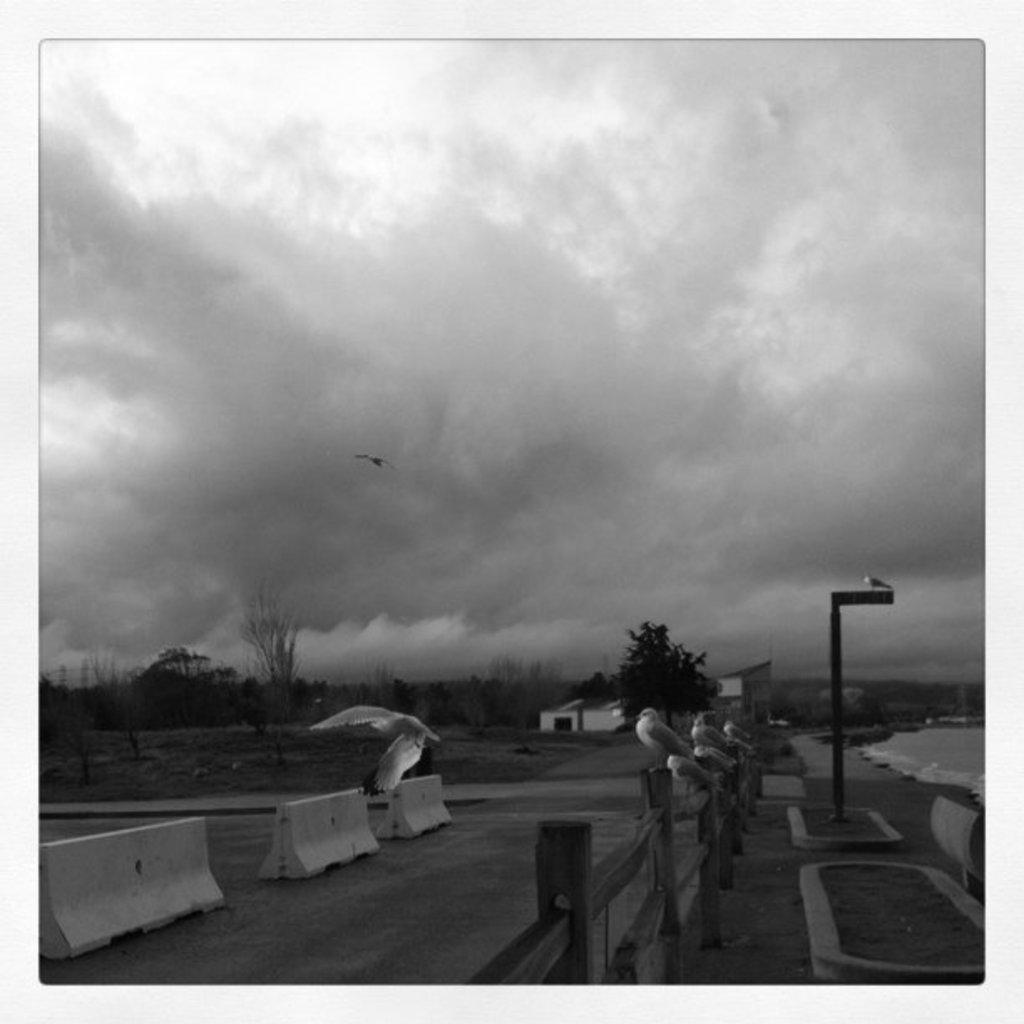What animals can be seen on the fencing in the image? There are birds on the fencing in the image. What type of vegetation is present in the image? There are trees in the image. What type of structures can be seen in the image? There are buildings in the image. What is visible in the background of the image? The sky is visible in the image. What type of collar can be seen on the bird in the image? There are no collars visible on the birds in the image, as they are not wearing any. What type of writing can be seen on the trees in the image? There is no writing present on the trees in the image; they are natural vegetation. 